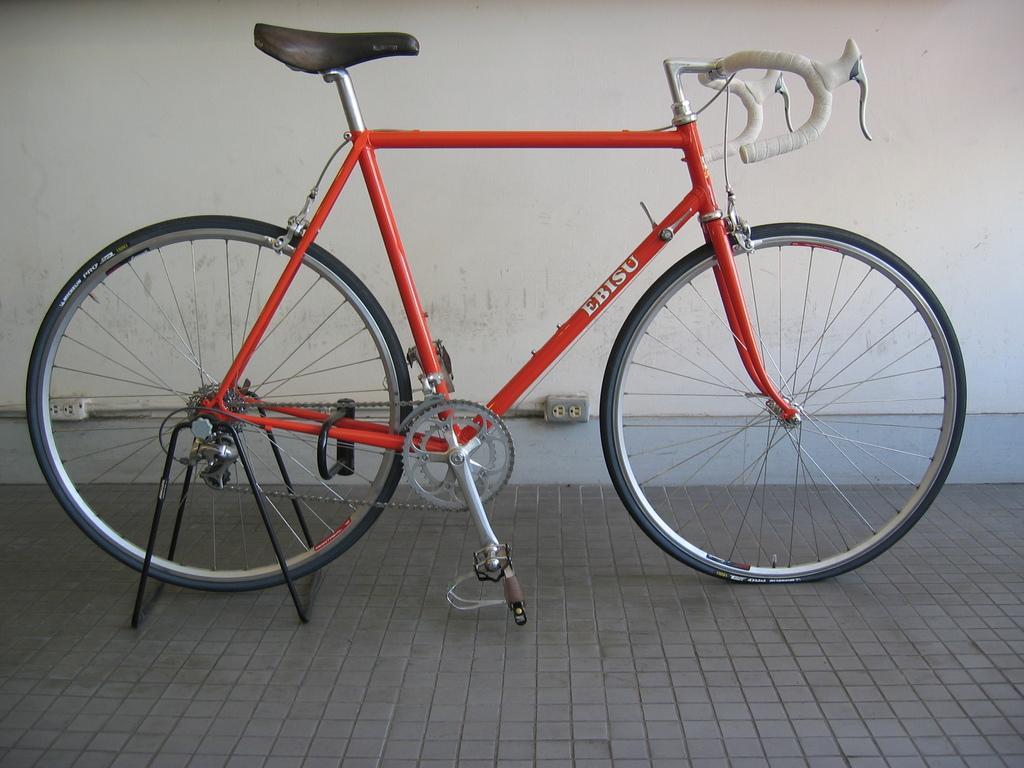In one or two sentences, can you explain what this image depicts? There is a bicycle in the center of the image. 